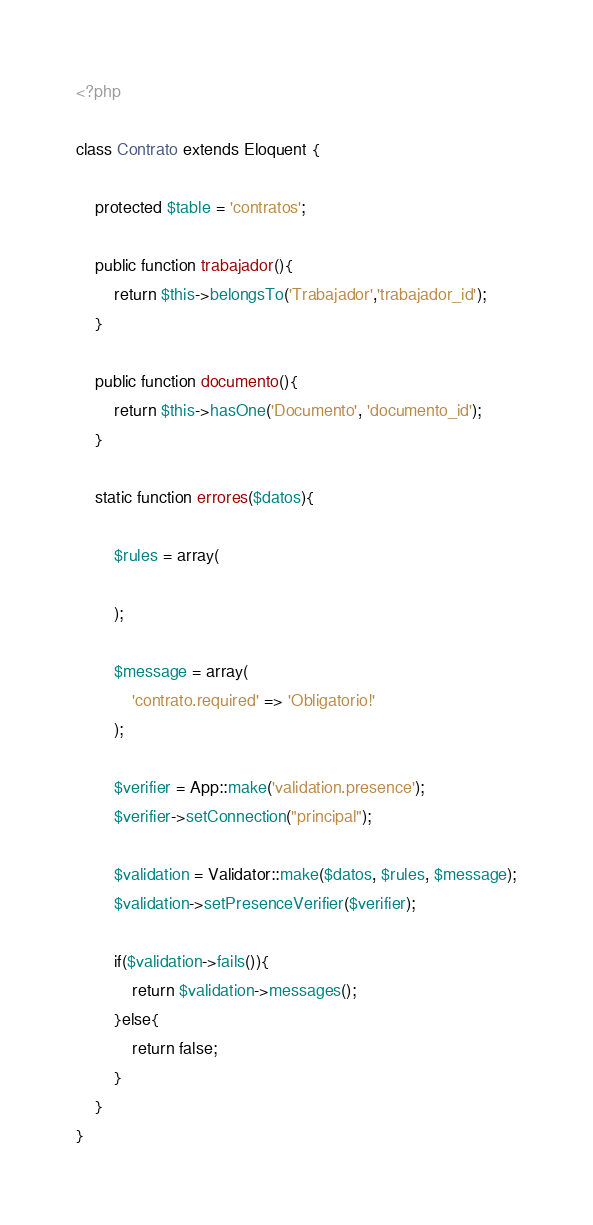Convert code to text. <code><loc_0><loc_0><loc_500><loc_500><_PHP_><?php

class Contrato extends Eloquent {
    
    protected $table = 'contratos';
    
    public function trabajador(){
        return $this->belongsTo('Trabajador','trabajador_id');
    }
    
    public function documento(){
        return $this->hasOne('Documento', 'documento_id');
    }

    static function errores($datos){
         
        $rules = array(

        );

        $message = array(
            'contrato.required' => 'Obligatorio!'
        );

        $verifier = App::make('validation.presence');
        $verifier->setConnection("principal");

        $validation = Validator::make($datos, $rules, $message);
        $validation->setPresenceVerifier($verifier);

        if($validation->fails()){
            return $validation->messages();
        }else{
            return false;
        }
    }
}</code> 